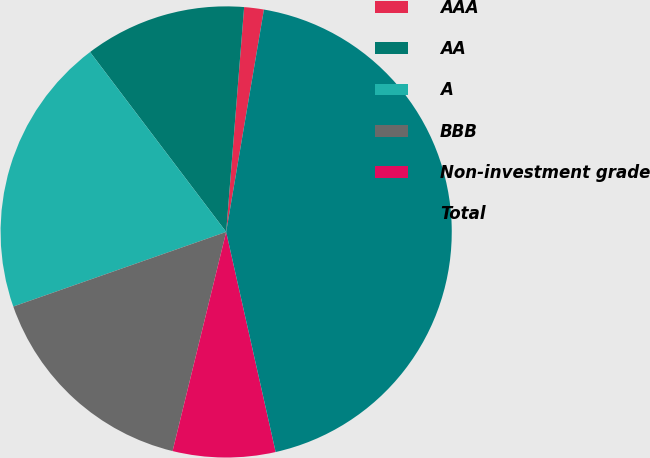<chart> <loc_0><loc_0><loc_500><loc_500><pie_chart><fcel>AAA<fcel>AA<fcel>A<fcel>BBB<fcel>Non-investment grade<fcel>Total<nl><fcel>1.41%<fcel>11.58%<fcel>20.06%<fcel>15.82%<fcel>7.34%<fcel>43.81%<nl></chart> 